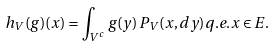Convert formula to latex. <formula><loc_0><loc_0><loc_500><loc_500>h _ { V } ( g ) ( x ) = \int _ { V ^ { c } } g ( y ) \, P _ { V } ( x , d y ) q . e . x \in E .</formula> 